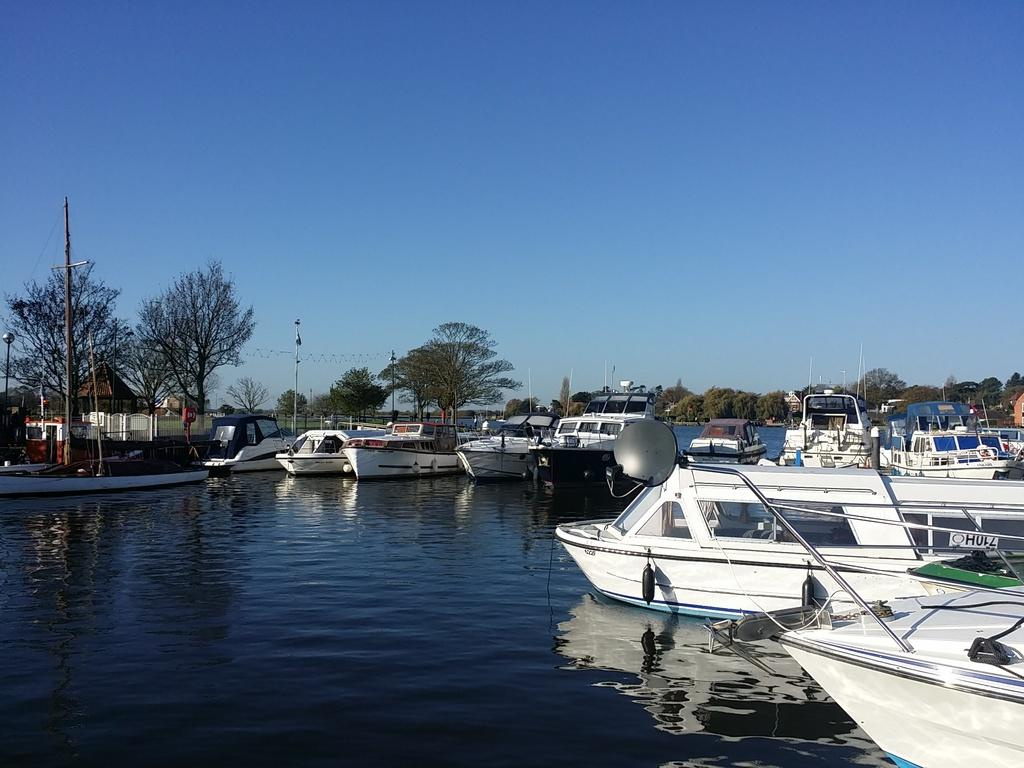What type of vehicles can be seen in the image? There are boats in the image. Where are the boats located? The boats are on the water. What type of natural environment is visible in the image? There are trees visible in the image. What object can be seen near the water's edge? There is a current pole in the image. What type of structure is present in the image? There is a small kind of house in the image. What part of the natural environment is visible above the water? The sky is visible in the image. What type of birthday celebration is taking place on the boats in the image? There is no indication of a birthday celebration in the image; it simply shows boats on the water. What sound can be heard coming from the boats in the image? There is no sound present in the image, as it is a still photograph. 